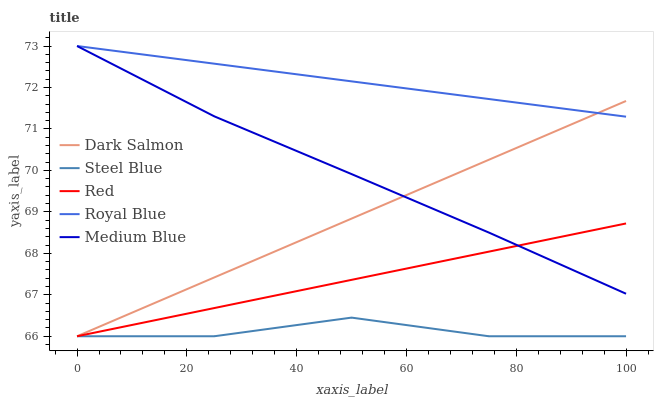Does Steel Blue have the minimum area under the curve?
Answer yes or no. Yes. Does Royal Blue have the maximum area under the curve?
Answer yes or no. Yes. Does Medium Blue have the minimum area under the curve?
Answer yes or no. No. Does Medium Blue have the maximum area under the curve?
Answer yes or no. No. Is Dark Salmon the smoothest?
Answer yes or no. Yes. Is Steel Blue the roughest?
Answer yes or no. Yes. Is Medium Blue the smoothest?
Answer yes or no. No. Is Medium Blue the roughest?
Answer yes or no. No. Does Dark Salmon have the lowest value?
Answer yes or no. Yes. Does Medium Blue have the lowest value?
Answer yes or no. No. Does Medium Blue have the highest value?
Answer yes or no. Yes. Does Dark Salmon have the highest value?
Answer yes or no. No. Is Red less than Royal Blue?
Answer yes or no. Yes. Is Medium Blue greater than Steel Blue?
Answer yes or no. Yes. Does Medium Blue intersect Royal Blue?
Answer yes or no. Yes. Is Medium Blue less than Royal Blue?
Answer yes or no. No. Is Medium Blue greater than Royal Blue?
Answer yes or no. No. Does Red intersect Royal Blue?
Answer yes or no. No. 